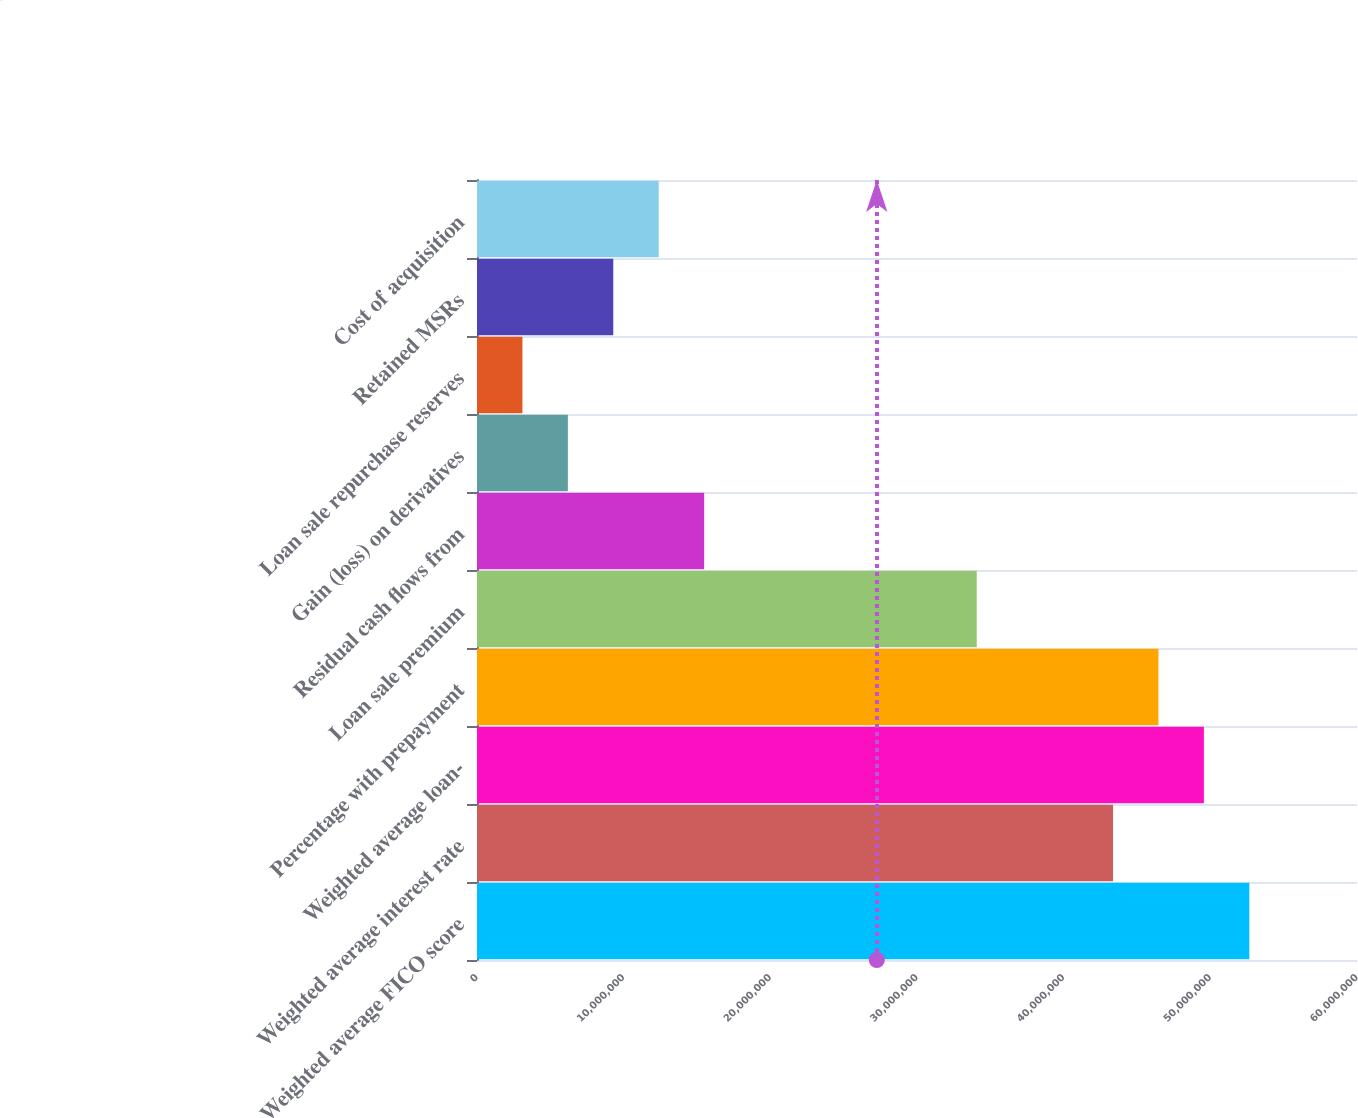Convert chart to OTSL. <chart><loc_0><loc_0><loc_500><loc_500><bar_chart><fcel>Weighted average FICO score<fcel>Weighted average interest rate<fcel>Weighted average loan-<fcel>Percentage with prepayment<fcel>Loan sale premium<fcel>Residual cash flows from<fcel>Gain (loss) on derivatives<fcel>Loan sale repurchase reserves<fcel>Retained MSRs<fcel>Cost of acquisition<nl><fcel>5.26584e+07<fcel>4.33657e+07<fcel>4.95608e+07<fcel>4.64633e+07<fcel>3.40731e+07<fcel>1.54878e+07<fcel>6.1951e+06<fcel>3.09755e+06<fcel>9.29266e+06<fcel>1.23902e+07<nl></chart> 